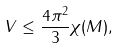<formula> <loc_0><loc_0><loc_500><loc_500>V \leq \frac { 4 \pi ^ { 2 } } { 3 } \chi ( M ) ,</formula> 